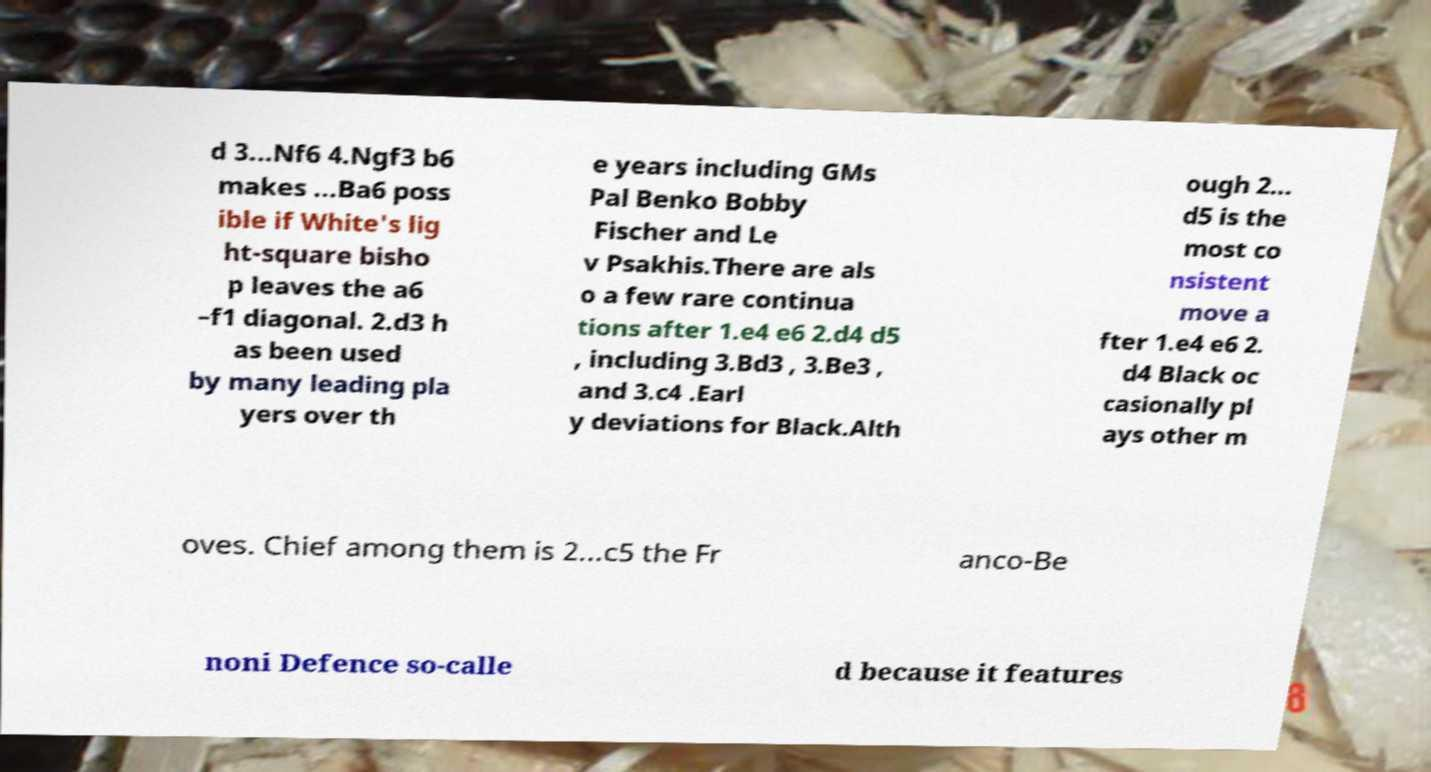Can you accurately transcribe the text from the provided image for me? d 3...Nf6 4.Ngf3 b6 makes ...Ba6 poss ible if White's lig ht-square bisho p leaves the a6 –f1 diagonal. 2.d3 h as been used by many leading pla yers over th e years including GMs Pal Benko Bobby Fischer and Le v Psakhis.There are als o a few rare continua tions after 1.e4 e6 2.d4 d5 , including 3.Bd3 , 3.Be3 , and 3.c4 .Earl y deviations for Black.Alth ough 2... d5 is the most co nsistent move a fter 1.e4 e6 2. d4 Black oc casionally pl ays other m oves. Chief among them is 2...c5 the Fr anco-Be noni Defence so-calle d because it features 